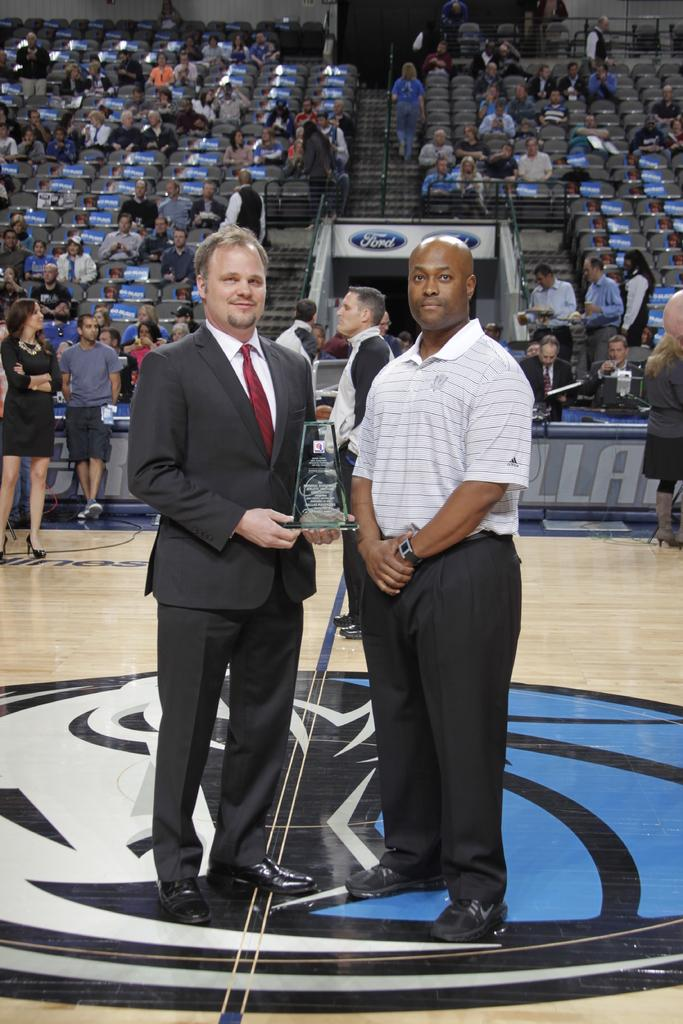What is happening in the image? There are people standing on a floor, and one man is holding an award in his hand. Can you describe the setting of the image? The people are standing on a floor, and there are people sitting on chairs in the background. What might the man holding the award be celebrating? It is not clear from the image what the man might be celebrating, but he is holding an award, which suggests some achievement or recognition. Where is the drain located in the image? There is no drain present in the image. What type of plot is being discussed by the people sitting on chairs? There is no discussion or plot visible in the image; it only shows people standing and sitting in a room. 